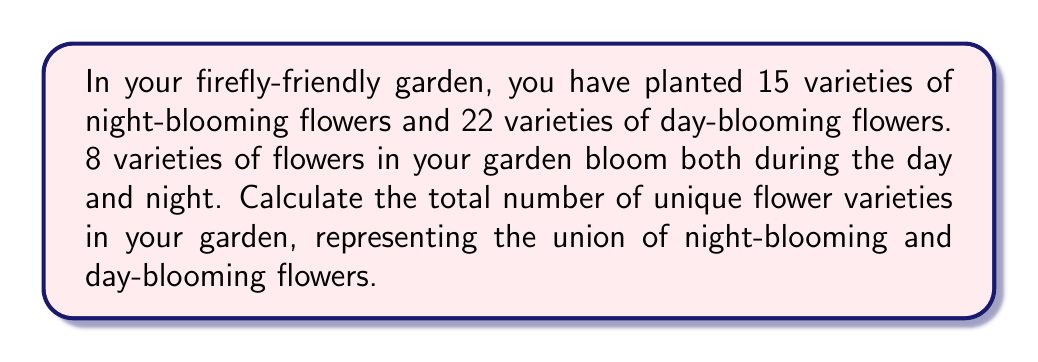Solve this math problem. To solve this problem, we need to use the concept of sets and their union. Let's define our sets:

$N$ = set of night-blooming flowers
$D$ = set of day-blooming flowers

We're given:
$|N| = 15$ (number of night-blooming varieties)
$|D| = 22$ (number of day-blooming varieties)
$|N \cap D| = 8$ (number of varieties that bloom both day and night)

We need to find $|N \cup D|$, which represents the total number of unique flower varieties.

We can use the formula for the cardinality of a union of two sets:

$$|N \cup D| = |N| + |D| - |N \cap D|$$

This formula accounts for the flowers that are in both sets, which would otherwise be counted twice if we simply added $|N|$ and $|D|$.

Substituting our known values:

$$|N \cup D| = 15 + 22 - 8$$

Calculating:

$$|N \cup D| = 37 - 8 = 29$$

Therefore, the total number of unique flower varieties in the garden is 29.
Answer: $29$ unique flower varieties 